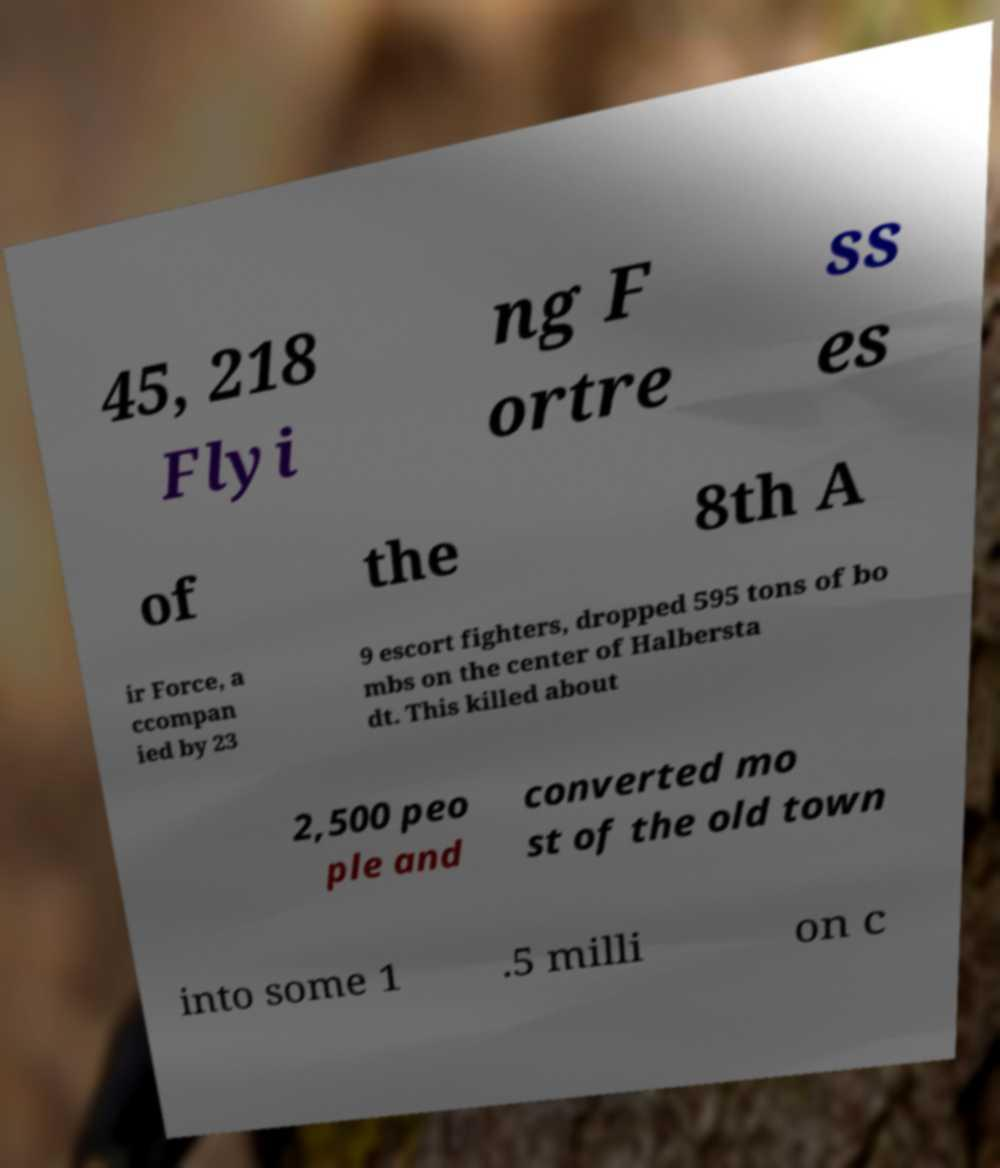What messages or text are displayed in this image? I need them in a readable, typed format. 45, 218 Flyi ng F ortre ss es of the 8th A ir Force, a ccompan ied by 23 9 escort fighters, dropped 595 tons of bo mbs on the center of Halbersta dt. This killed about 2,500 peo ple and converted mo st of the old town into some 1 .5 milli on c 